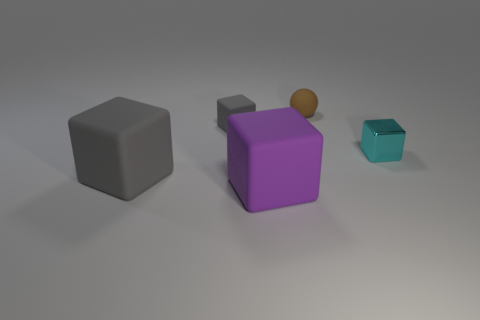Add 3 purple cubes. How many objects exist? 8 Subtract all blocks. How many objects are left? 1 Add 1 small brown things. How many small brown things exist? 2 Subtract 0 gray cylinders. How many objects are left? 5 Subtract all brown balls. Subtract all yellow shiny things. How many objects are left? 4 Add 3 cyan metal cubes. How many cyan metal cubes are left? 4 